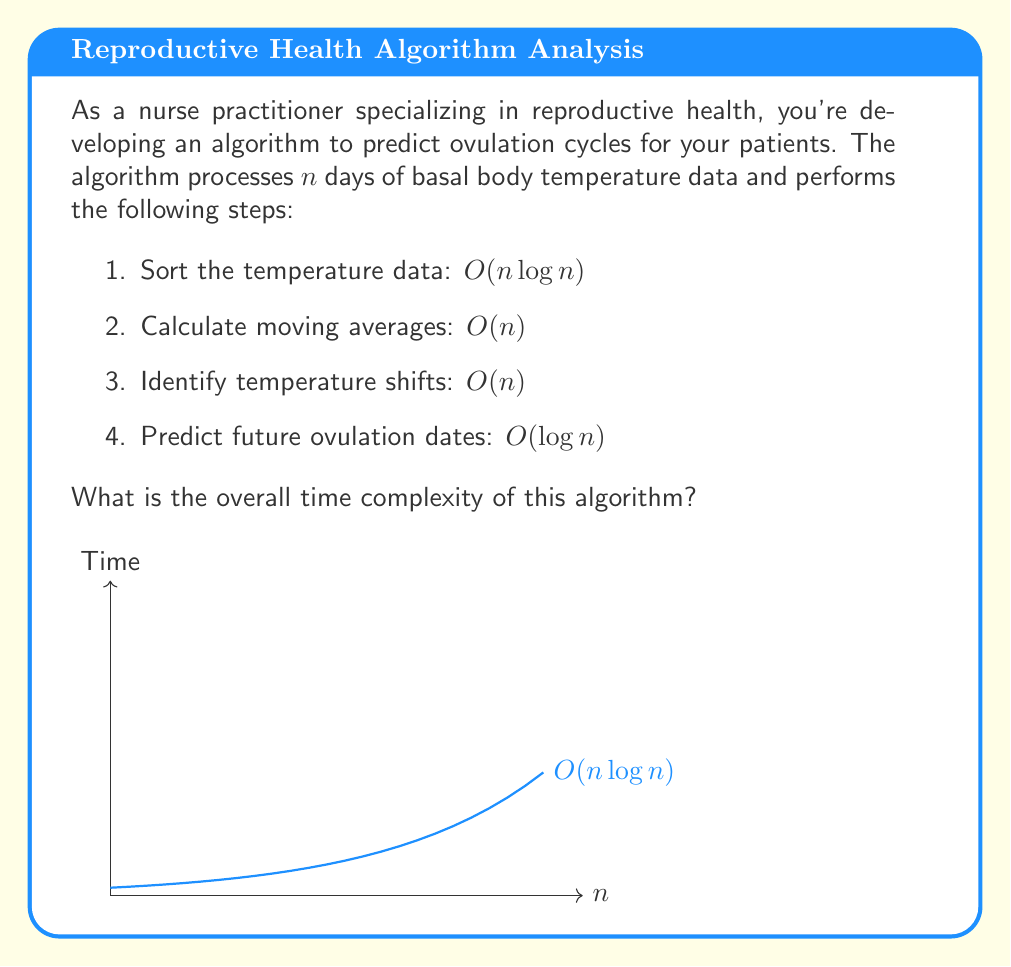Provide a solution to this math problem. To determine the overall time complexity of the algorithm, we need to analyze each step and identify the dominant term:

1. Sorting the temperature data: $O(n \log n)$
   This is typically done using efficient sorting algorithms like Merge Sort or Quick Sort.

2. Calculating moving averages: $O(n)$
   This involves a single pass through the data.

3. Identifying temperature shifts: $O(n)$
   Another single pass through the data.

4. Predicting future ovulation dates: $O(\log n)$
   This step likely involves binary search or similar logarithmic-time operations.

The total time complexity is the sum of these individual complexities:

$$O(n \log n) + O(n) + O(n) + O(\log n)$$

Simplifying:
$$O(n \log n) + O(n) + O(\log n)$$

In Big O notation, we only consider the dominant term. Since $n \log n$ grows faster than both $n$ and $\log n$ for large values of $n$, it dominates the expression.

Therefore, the overall time complexity of the algorithm is $O(n \log n)$.
Answer: $O(n \log n)$ 